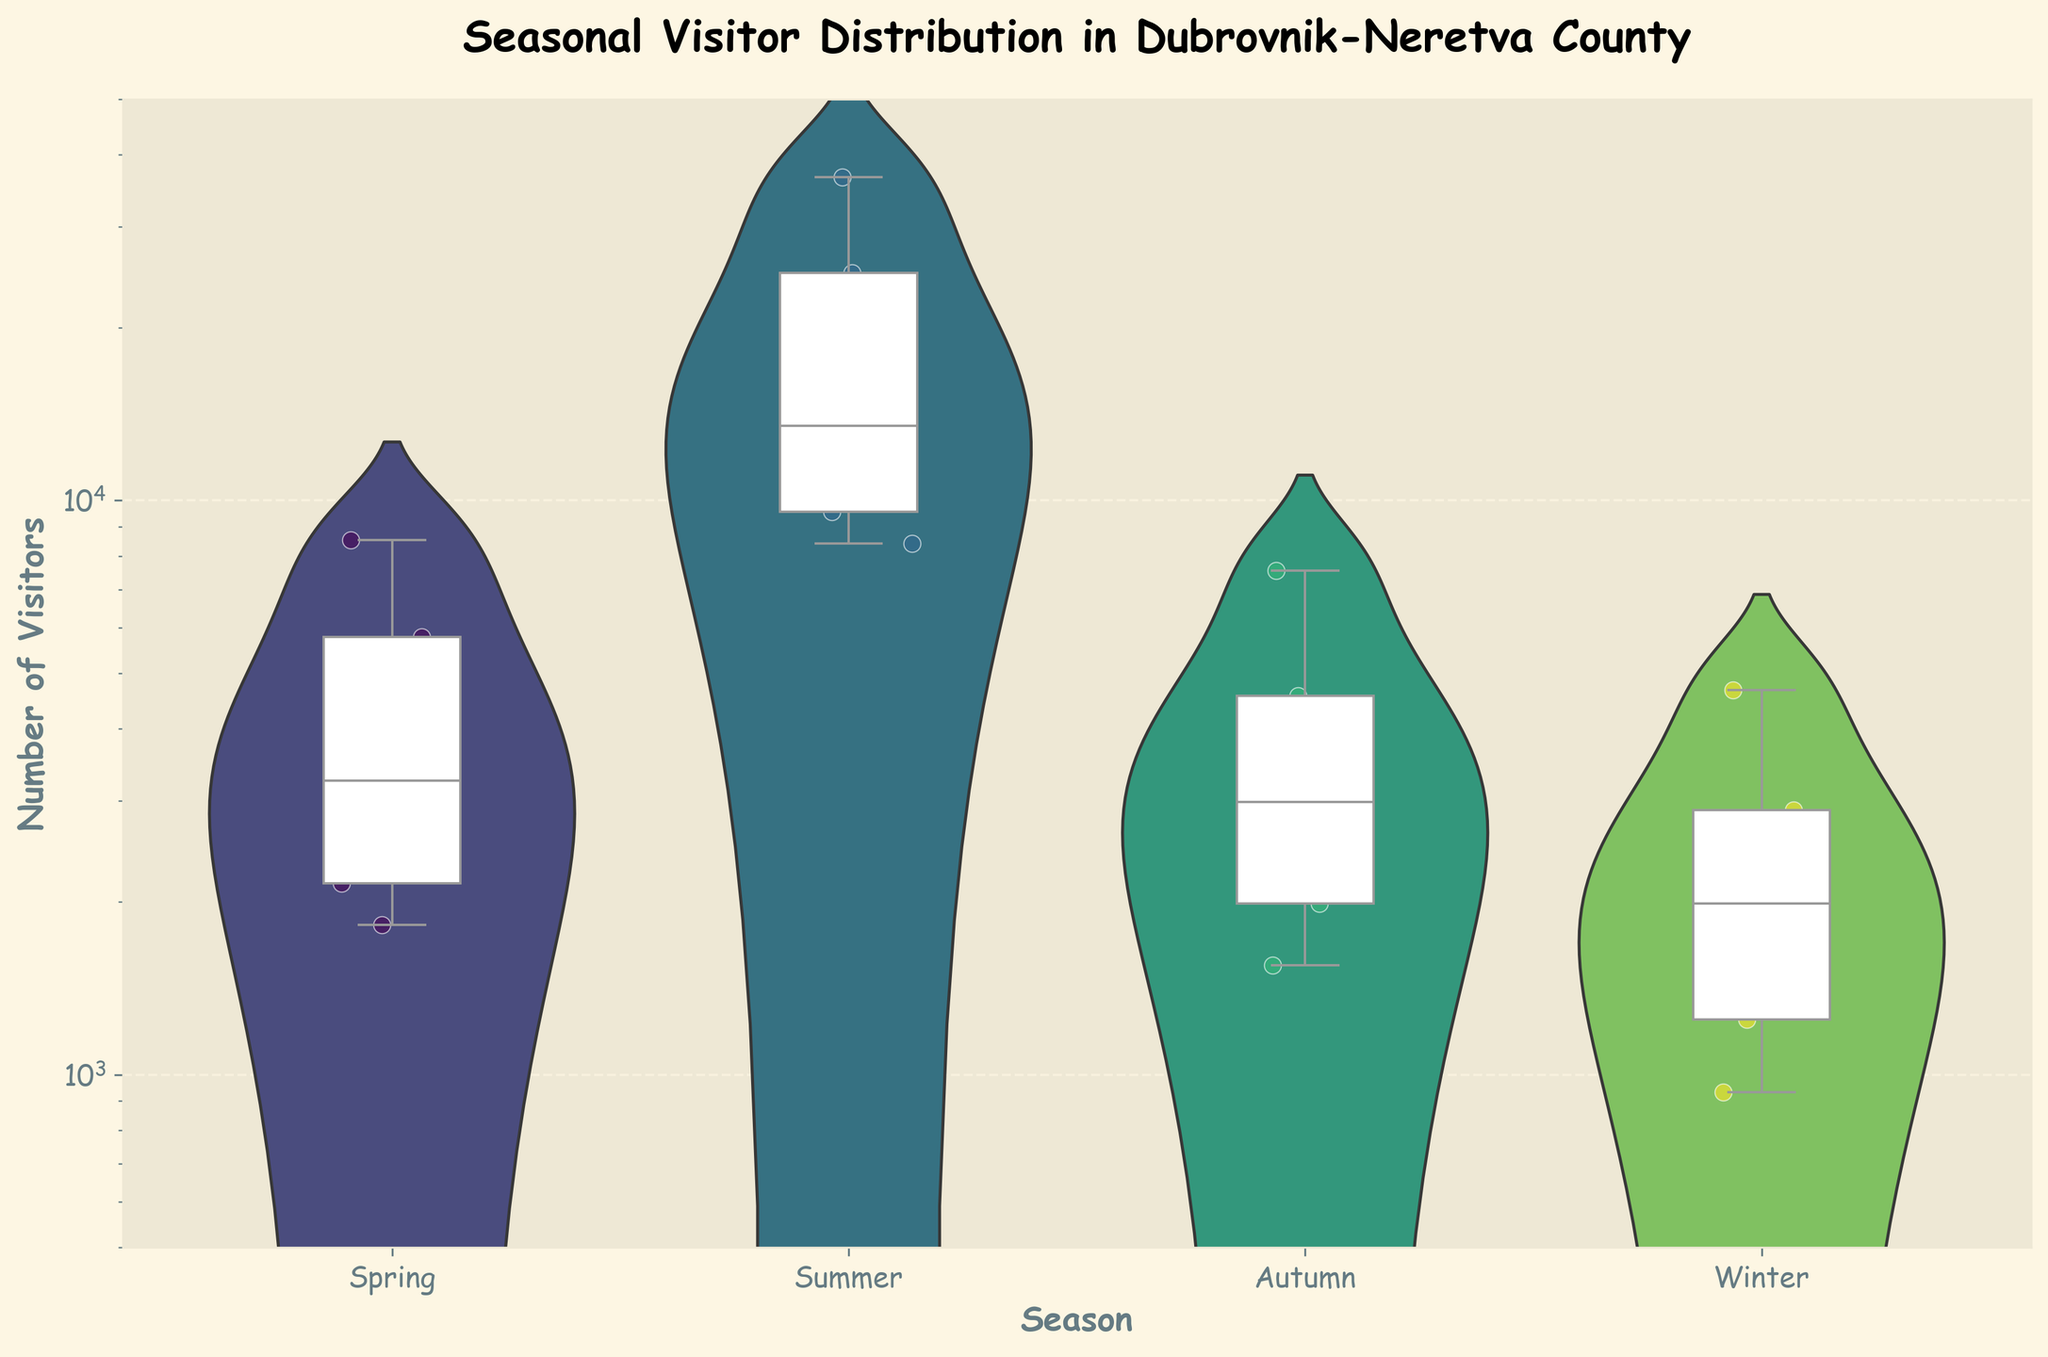What is the title of the plot? The title can be found at the top of the plot and it typically describes what the plot is about.
Answer: Seasonal Visitor Distribution in Dubrovnik-Neretva County Which season has the highest number of visitors? By looking at the violin plots and the scales, summer shows the highest numbers. This can be seen from the widest section of the violin plot as well as the positions of the box plots.
Answer: Summer How does the number of visitors in Autumn compare to Winter? By examining the violin plots and the box plots, Autumn has a higher number of visitors as its violin plot is wider and higher compared to Winter.
Answer: Autumn has more visitors What is the median number of visitors in Summer? The median is represented by the horizontal line inside the box plot. In Summer, this line is approximately at the 20,000 mark.
Answer: Around 20,000 Is there more variability in visitor numbers during Spring or Autumn? Variability is indicated by the width and spread of the violin plots and the length of the box plots' whiskers. Spring shows greater spread and wider range compared to Autumn.
Answer: Spring What is the range of visitor numbers in Winter? The range is determined by comparing the minimum and maximum values depicted by the whiskers of the box plot. Winter's box plot shows a range approximately from 1000 to 5000.
Answer: 1000 to 5000 Which season's visitor distribution is the most skewed? Skewness can be inferred by the shape of the violin plot. Summer's distribution appears most skewed with a long tail extending to higher values.
Answer: Summer How are the visitor numbers distributed in Spring? The violin plot in Spring indicates that the distribution is more spread out and has a wider range in the middle compared to Autumn and Winter.
Answer: More spread out What can you infer about visitor numbers in Lastovo compared to Dubrovnik across all seasons? By analyzing the scatter plots overlaid, it is clear that Dubrovnik consistently has higher visitor numbers compared to Lastovo in each season.
Answer: Dubrovnik has more visitors 